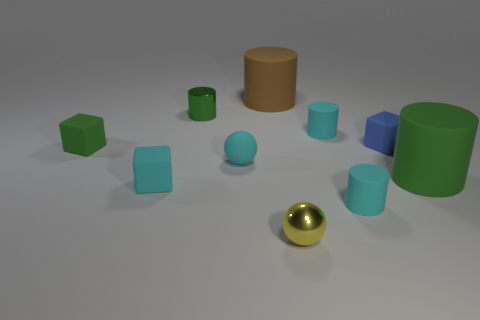What might be the context or purpose of this arrangement? This setup appears to be a minimalist composition, possibly for demonstrating color theory or 3D modeling. It could serve an educational purpose, showcasing geometric forms and color contrasts, or simply exist as an artistic display meant to provoke thought on the interplay between shapes and colors. Could these objects represent anything in a symbolic or thematic way? Symbolically, the objects could be seen as individuals in a community, each with unique attributes yet part of a larger whole. Thematically, they may represent diversity and individuality, with the singular golden sphere perhaps symbolizing a focal point of unique value or a guiding principle within a society. 